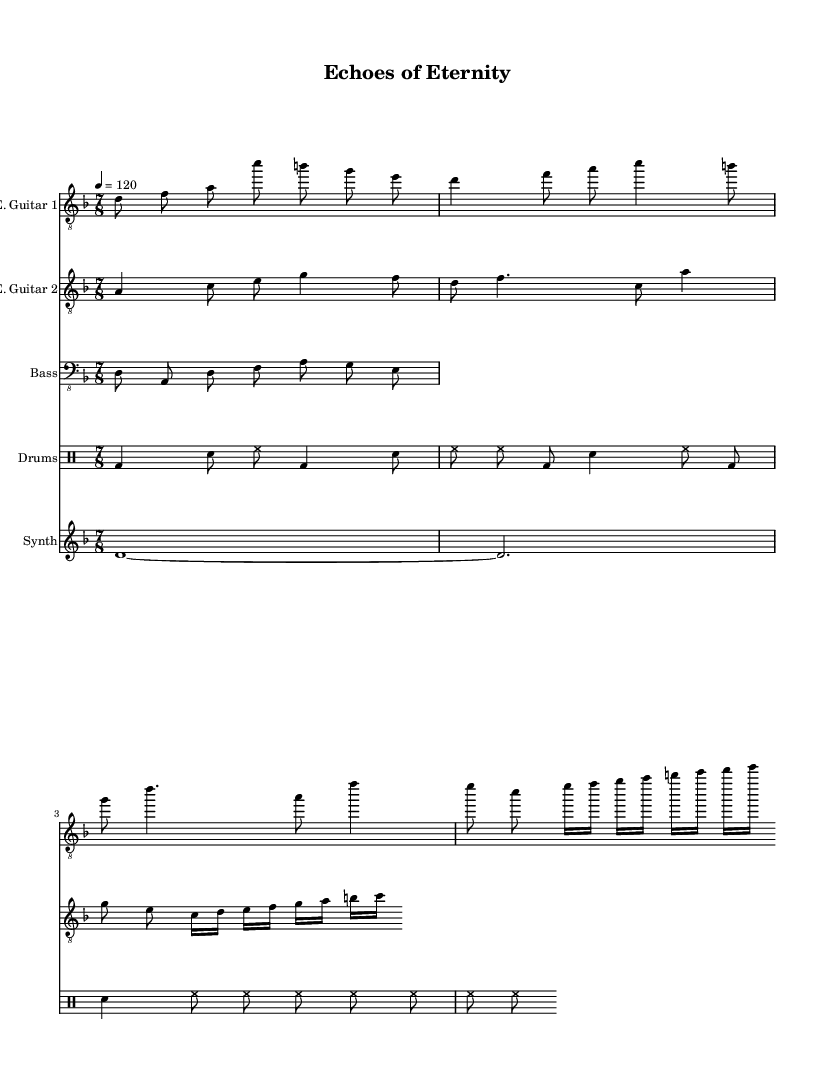What is the key signature of this music? The key signature is D minor, which has one flat (B flat) and indicates the tonality of the piece.
Answer: D minor What is the time signature of the piece? The time signature is 7/8, meaning there are seven eighth notes in each measure, which gives an irregular but progressive feel often found in progressive metal.
Answer: 7/8 What is the tempo marking for this composition? The tempo marking is 4 equals 120, indicating that the quarter note beats at a speed of 120 beats per minute.
Answer: 120 How many distinct sections can be identified in the electric guitar part? The electric guitar part includes a main riff, a verse, a chorus, and a bridge, totaling four distinct sections. Recognizing such sections is essential for understanding the song's structure and flow.
Answer: Four Which instruments are playing the main melody in this piece? The main melody is shared between the two electric guitars, demonstrating a typical characteristic of metal music where multiple guitars create a rich harmonic and melodic texture.
Answer: Two electric guitars What is the rhythmic pattern of the drum section? The drum section alternates between bass and snare hits, creating a driving rhythm that complements the complex meter of the music, common in progressive metal. This pattern includes syncopation and layered textures typical of the genre.
Answer: Alternating bass and snare What philosophical theme can be inferred from the title "Echoes of Eternity"? The title suggests themes of time, existence, or the cyclical nature of life, which are common concepts explored in progressive metal, often leading to deeper reflection within the music's narrative.
Answer: Time and existence 